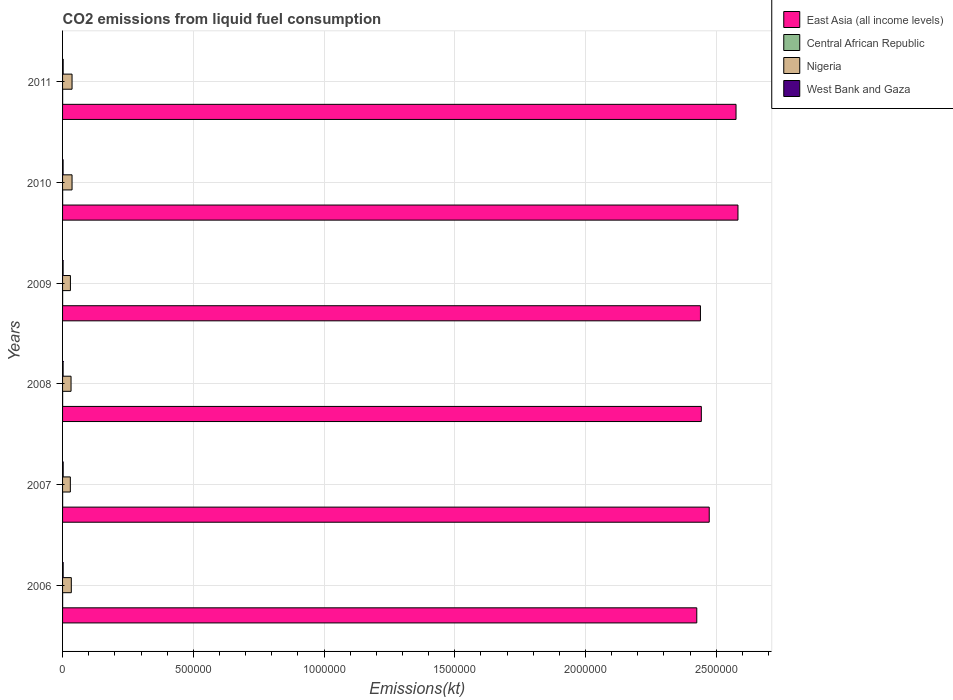How many groups of bars are there?
Keep it short and to the point. 6. Are the number of bars per tick equal to the number of legend labels?
Your answer should be very brief. Yes. How many bars are there on the 5th tick from the top?
Provide a short and direct response. 4. How many bars are there on the 2nd tick from the bottom?
Keep it short and to the point. 4. What is the label of the 5th group of bars from the top?
Make the answer very short. 2007. In how many cases, is the number of bars for a given year not equal to the number of legend labels?
Make the answer very short. 0. What is the amount of CO2 emitted in West Bank and Gaza in 2007?
Keep it short and to the point. 2324.88. Across all years, what is the maximum amount of CO2 emitted in East Asia (all income levels)?
Offer a very short reply. 2.58e+06. Across all years, what is the minimum amount of CO2 emitted in Nigeria?
Offer a terse response. 2.98e+04. In which year was the amount of CO2 emitted in West Bank and Gaza maximum?
Your answer should be very brief. 2007. In which year was the amount of CO2 emitted in Nigeria minimum?
Your response must be concise. 2007. What is the total amount of CO2 emitted in Central African Republic in the graph?
Give a very brief answer. 1481.47. What is the difference between the amount of CO2 emitted in West Bank and Gaza in 2006 and that in 2010?
Offer a very short reply. 231.02. What is the difference between the amount of CO2 emitted in Central African Republic in 2006 and the amount of CO2 emitted in Nigeria in 2007?
Provide a succinct answer. -2.95e+04. What is the average amount of CO2 emitted in Central African Republic per year?
Offer a terse response. 246.91. In the year 2010, what is the difference between the amount of CO2 emitted in West Bank and Gaza and amount of CO2 emitted in Nigeria?
Your answer should be very brief. -3.42e+04. What is the ratio of the amount of CO2 emitted in West Bank and Gaza in 2009 to that in 2010?
Offer a terse response. 1.03. What is the difference between the highest and the second highest amount of CO2 emitted in West Bank and Gaza?
Offer a very short reply. 58.67. What is the difference between the highest and the lowest amount of CO2 emitted in West Bank and Gaza?
Your response must be concise. 289.69. In how many years, is the amount of CO2 emitted in West Bank and Gaza greater than the average amount of CO2 emitted in West Bank and Gaza taken over all years?
Provide a short and direct response. 3. Is the sum of the amount of CO2 emitted in Central African Republic in 2008 and 2009 greater than the maximum amount of CO2 emitted in West Bank and Gaza across all years?
Make the answer very short. No. Is it the case that in every year, the sum of the amount of CO2 emitted in West Bank and Gaza and amount of CO2 emitted in Nigeria is greater than the sum of amount of CO2 emitted in East Asia (all income levels) and amount of CO2 emitted in Central African Republic?
Your answer should be compact. No. What does the 4th bar from the top in 2008 represents?
Give a very brief answer. East Asia (all income levels). What does the 1st bar from the bottom in 2011 represents?
Provide a short and direct response. East Asia (all income levels). Is it the case that in every year, the sum of the amount of CO2 emitted in West Bank and Gaza and amount of CO2 emitted in Central African Republic is greater than the amount of CO2 emitted in East Asia (all income levels)?
Ensure brevity in your answer.  No. How many bars are there?
Offer a terse response. 24. Are all the bars in the graph horizontal?
Your answer should be compact. Yes. How many years are there in the graph?
Give a very brief answer. 6. Does the graph contain any zero values?
Provide a succinct answer. No. Does the graph contain grids?
Your answer should be very brief. Yes. Where does the legend appear in the graph?
Provide a succinct answer. Top right. How are the legend labels stacked?
Your answer should be compact. Vertical. What is the title of the graph?
Give a very brief answer. CO2 emissions from liquid fuel consumption. What is the label or title of the X-axis?
Provide a succinct answer. Emissions(kt). What is the label or title of the Y-axis?
Offer a terse response. Years. What is the Emissions(kt) in East Asia (all income levels) in 2006?
Give a very brief answer. 2.43e+06. What is the Emissions(kt) of Central African Republic in 2006?
Offer a very short reply. 227.35. What is the Emissions(kt) in Nigeria in 2006?
Offer a very short reply. 3.35e+04. What is the Emissions(kt) in West Bank and Gaza in 2006?
Give a very brief answer. 2266.21. What is the Emissions(kt) of East Asia (all income levels) in 2007?
Provide a short and direct response. 2.47e+06. What is the Emissions(kt) of Central African Republic in 2007?
Offer a terse response. 234.69. What is the Emissions(kt) of Nigeria in 2007?
Keep it short and to the point. 2.98e+04. What is the Emissions(kt) in West Bank and Gaza in 2007?
Keep it short and to the point. 2324.88. What is the Emissions(kt) in East Asia (all income levels) in 2008?
Offer a very short reply. 2.44e+06. What is the Emissions(kt) in Central African Republic in 2008?
Ensure brevity in your answer.  234.69. What is the Emissions(kt) of Nigeria in 2008?
Your answer should be compact. 3.25e+04. What is the Emissions(kt) in West Bank and Gaza in 2008?
Offer a very short reply. 2053.52. What is the Emissions(kt) in East Asia (all income levels) in 2009?
Offer a very short reply. 2.44e+06. What is the Emissions(kt) of Central African Republic in 2009?
Make the answer very short. 234.69. What is the Emissions(kt) of Nigeria in 2009?
Make the answer very short. 3.00e+04. What is the Emissions(kt) in West Bank and Gaza in 2009?
Your answer should be very brief. 2090.19. What is the Emissions(kt) in East Asia (all income levels) in 2010?
Your answer should be very brief. 2.58e+06. What is the Emissions(kt) of Central African Republic in 2010?
Give a very brief answer. 264.02. What is the Emissions(kt) of Nigeria in 2010?
Keep it short and to the point. 3.63e+04. What is the Emissions(kt) in West Bank and Gaza in 2010?
Make the answer very short. 2035.18. What is the Emissions(kt) in East Asia (all income levels) in 2011?
Your answer should be very brief. 2.58e+06. What is the Emissions(kt) of Central African Republic in 2011?
Your response must be concise. 286.03. What is the Emissions(kt) of Nigeria in 2011?
Your answer should be very brief. 3.63e+04. What is the Emissions(kt) in West Bank and Gaza in 2011?
Offer a terse response. 2247.87. Across all years, what is the maximum Emissions(kt) of East Asia (all income levels)?
Offer a very short reply. 2.58e+06. Across all years, what is the maximum Emissions(kt) in Central African Republic?
Provide a short and direct response. 286.03. Across all years, what is the maximum Emissions(kt) in Nigeria?
Your answer should be compact. 3.63e+04. Across all years, what is the maximum Emissions(kt) in West Bank and Gaza?
Ensure brevity in your answer.  2324.88. Across all years, what is the minimum Emissions(kt) in East Asia (all income levels)?
Give a very brief answer. 2.43e+06. Across all years, what is the minimum Emissions(kt) of Central African Republic?
Keep it short and to the point. 227.35. Across all years, what is the minimum Emissions(kt) of Nigeria?
Ensure brevity in your answer.  2.98e+04. Across all years, what is the minimum Emissions(kt) in West Bank and Gaza?
Provide a succinct answer. 2035.18. What is the total Emissions(kt) of East Asia (all income levels) in the graph?
Keep it short and to the point. 1.49e+07. What is the total Emissions(kt) of Central African Republic in the graph?
Offer a terse response. 1481.47. What is the total Emissions(kt) in Nigeria in the graph?
Your response must be concise. 1.98e+05. What is the total Emissions(kt) of West Bank and Gaza in the graph?
Keep it short and to the point. 1.30e+04. What is the difference between the Emissions(kt) in East Asia (all income levels) in 2006 and that in 2007?
Your response must be concise. -4.77e+04. What is the difference between the Emissions(kt) of Central African Republic in 2006 and that in 2007?
Offer a terse response. -7.33. What is the difference between the Emissions(kt) in Nigeria in 2006 and that in 2007?
Your answer should be very brief. 3722.01. What is the difference between the Emissions(kt) in West Bank and Gaza in 2006 and that in 2007?
Provide a succinct answer. -58.67. What is the difference between the Emissions(kt) in East Asia (all income levels) in 2006 and that in 2008?
Make the answer very short. -1.74e+04. What is the difference between the Emissions(kt) of Central African Republic in 2006 and that in 2008?
Make the answer very short. -7.33. What is the difference between the Emissions(kt) in Nigeria in 2006 and that in 2008?
Your response must be concise. 1015.76. What is the difference between the Emissions(kt) of West Bank and Gaza in 2006 and that in 2008?
Provide a short and direct response. 212.69. What is the difference between the Emissions(kt) in East Asia (all income levels) in 2006 and that in 2009?
Ensure brevity in your answer.  -1.40e+04. What is the difference between the Emissions(kt) in Central African Republic in 2006 and that in 2009?
Offer a very short reply. -7.33. What is the difference between the Emissions(kt) of Nigeria in 2006 and that in 2009?
Keep it short and to the point. 3439.65. What is the difference between the Emissions(kt) of West Bank and Gaza in 2006 and that in 2009?
Provide a succinct answer. 176.02. What is the difference between the Emissions(kt) of East Asia (all income levels) in 2006 and that in 2010?
Keep it short and to the point. -1.58e+05. What is the difference between the Emissions(kt) in Central African Republic in 2006 and that in 2010?
Your answer should be very brief. -36.67. What is the difference between the Emissions(kt) of Nigeria in 2006 and that in 2010?
Give a very brief answer. -2794.25. What is the difference between the Emissions(kt) in West Bank and Gaza in 2006 and that in 2010?
Keep it short and to the point. 231.02. What is the difference between the Emissions(kt) in East Asia (all income levels) in 2006 and that in 2011?
Offer a very short reply. -1.50e+05. What is the difference between the Emissions(kt) of Central African Republic in 2006 and that in 2011?
Provide a short and direct response. -58.67. What is the difference between the Emissions(kt) of Nigeria in 2006 and that in 2011?
Keep it short and to the point. -2805.26. What is the difference between the Emissions(kt) in West Bank and Gaza in 2006 and that in 2011?
Your answer should be compact. 18.34. What is the difference between the Emissions(kt) of East Asia (all income levels) in 2007 and that in 2008?
Your answer should be very brief. 3.02e+04. What is the difference between the Emissions(kt) in Nigeria in 2007 and that in 2008?
Provide a succinct answer. -2706.25. What is the difference between the Emissions(kt) in West Bank and Gaza in 2007 and that in 2008?
Your answer should be very brief. 271.36. What is the difference between the Emissions(kt) of East Asia (all income levels) in 2007 and that in 2009?
Offer a very short reply. 3.36e+04. What is the difference between the Emissions(kt) in Central African Republic in 2007 and that in 2009?
Provide a succinct answer. 0. What is the difference between the Emissions(kt) in Nigeria in 2007 and that in 2009?
Provide a short and direct response. -282.36. What is the difference between the Emissions(kt) of West Bank and Gaza in 2007 and that in 2009?
Make the answer very short. 234.69. What is the difference between the Emissions(kt) in East Asia (all income levels) in 2007 and that in 2010?
Your answer should be very brief. -1.10e+05. What is the difference between the Emissions(kt) of Central African Republic in 2007 and that in 2010?
Keep it short and to the point. -29.34. What is the difference between the Emissions(kt) of Nigeria in 2007 and that in 2010?
Your answer should be compact. -6516.26. What is the difference between the Emissions(kt) of West Bank and Gaza in 2007 and that in 2010?
Provide a succinct answer. 289.69. What is the difference between the Emissions(kt) of East Asia (all income levels) in 2007 and that in 2011?
Offer a very short reply. -1.02e+05. What is the difference between the Emissions(kt) in Central African Republic in 2007 and that in 2011?
Ensure brevity in your answer.  -51.34. What is the difference between the Emissions(kt) in Nigeria in 2007 and that in 2011?
Ensure brevity in your answer.  -6527.26. What is the difference between the Emissions(kt) in West Bank and Gaza in 2007 and that in 2011?
Provide a short and direct response. 77.01. What is the difference between the Emissions(kt) in East Asia (all income levels) in 2008 and that in 2009?
Make the answer very short. 3400.93. What is the difference between the Emissions(kt) in Central African Republic in 2008 and that in 2009?
Your answer should be very brief. 0. What is the difference between the Emissions(kt) in Nigeria in 2008 and that in 2009?
Your response must be concise. 2423.89. What is the difference between the Emissions(kt) of West Bank and Gaza in 2008 and that in 2009?
Provide a succinct answer. -36.67. What is the difference between the Emissions(kt) in East Asia (all income levels) in 2008 and that in 2010?
Offer a terse response. -1.40e+05. What is the difference between the Emissions(kt) in Central African Republic in 2008 and that in 2010?
Your answer should be compact. -29.34. What is the difference between the Emissions(kt) in Nigeria in 2008 and that in 2010?
Offer a very short reply. -3810.01. What is the difference between the Emissions(kt) of West Bank and Gaza in 2008 and that in 2010?
Give a very brief answer. 18.34. What is the difference between the Emissions(kt) of East Asia (all income levels) in 2008 and that in 2011?
Ensure brevity in your answer.  -1.33e+05. What is the difference between the Emissions(kt) of Central African Republic in 2008 and that in 2011?
Make the answer very short. -51.34. What is the difference between the Emissions(kt) of Nigeria in 2008 and that in 2011?
Make the answer very short. -3821.01. What is the difference between the Emissions(kt) in West Bank and Gaza in 2008 and that in 2011?
Your response must be concise. -194.35. What is the difference between the Emissions(kt) in East Asia (all income levels) in 2009 and that in 2010?
Provide a short and direct response. -1.44e+05. What is the difference between the Emissions(kt) in Central African Republic in 2009 and that in 2010?
Your answer should be compact. -29.34. What is the difference between the Emissions(kt) of Nigeria in 2009 and that in 2010?
Make the answer very short. -6233.9. What is the difference between the Emissions(kt) of West Bank and Gaza in 2009 and that in 2010?
Your response must be concise. 55.01. What is the difference between the Emissions(kt) in East Asia (all income levels) in 2009 and that in 2011?
Your answer should be compact. -1.36e+05. What is the difference between the Emissions(kt) of Central African Republic in 2009 and that in 2011?
Keep it short and to the point. -51.34. What is the difference between the Emissions(kt) in Nigeria in 2009 and that in 2011?
Your response must be concise. -6244.9. What is the difference between the Emissions(kt) in West Bank and Gaza in 2009 and that in 2011?
Offer a very short reply. -157.68. What is the difference between the Emissions(kt) of East Asia (all income levels) in 2010 and that in 2011?
Your answer should be compact. 7429.65. What is the difference between the Emissions(kt) in Central African Republic in 2010 and that in 2011?
Give a very brief answer. -22. What is the difference between the Emissions(kt) of Nigeria in 2010 and that in 2011?
Offer a very short reply. -11. What is the difference between the Emissions(kt) in West Bank and Gaza in 2010 and that in 2011?
Give a very brief answer. -212.69. What is the difference between the Emissions(kt) in East Asia (all income levels) in 2006 and the Emissions(kt) in Central African Republic in 2007?
Provide a succinct answer. 2.43e+06. What is the difference between the Emissions(kt) in East Asia (all income levels) in 2006 and the Emissions(kt) in Nigeria in 2007?
Provide a short and direct response. 2.40e+06. What is the difference between the Emissions(kt) of East Asia (all income levels) in 2006 and the Emissions(kt) of West Bank and Gaza in 2007?
Your answer should be compact. 2.42e+06. What is the difference between the Emissions(kt) of Central African Republic in 2006 and the Emissions(kt) of Nigeria in 2007?
Your response must be concise. -2.95e+04. What is the difference between the Emissions(kt) of Central African Republic in 2006 and the Emissions(kt) of West Bank and Gaza in 2007?
Give a very brief answer. -2097.52. What is the difference between the Emissions(kt) of Nigeria in 2006 and the Emissions(kt) of West Bank and Gaza in 2007?
Offer a terse response. 3.12e+04. What is the difference between the Emissions(kt) of East Asia (all income levels) in 2006 and the Emissions(kt) of Central African Republic in 2008?
Your answer should be very brief. 2.43e+06. What is the difference between the Emissions(kt) of East Asia (all income levels) in 2006 and the Emissions(kt) of Nigeria in 2008?
Make the answer very short. 2.39e+06. What is the difference between the Emissions(kt) in East Asia (all income levels) in 2006 and the Emissions(kt) in West Bank and Gaza in 2008?
Offer a very short reply. 2.42e+06. What is the difference between the Emissions(kt) in Central African Republic in 2006 and the Emissions(kt) in Nigeria in 2008?
Ensure brevity in your answer.  -3.22e+04. What is the difference between the Emissions(kt) of Central African Republic in 2006 and the Emissions(kt) of West Bank and Gaza in 2008?
Ensure brevity in your answer.  -1826.17. What is the difference between the Emissions(kt) of Nigeria in 2006 and the Emissions(kt) of West Bank and Gaza in 2008?
Provide a succinct answer. 3.14e+04. What is the difference between the Emissions(kt) in East Asia (all income levels) in 2006 and the Emissions(kt) in Central African Republic in 2009?
Keep it short and to the point. 2.43e+06. What is the difference between the Emissions(kt) of East Asia (all income levels) in 2006 and the Emissions(kt) of Nigeria in 2009?
Give a very brief answer. 2.40e+06. What is the difference between the Emissions(kt) of East Asia (all income levels) in 2006 and the Emissions(kt) of West Bank and Gaza in 2009?
Your answer should be compact. 2.42e+06. What is the difference between the Emissions(kt) in Central African Republic in 2006 and the Emissions(kt) in Nigeria in 2009?
Offer a very short reply. -2.98e+04. What is the difference between the Emissions(kt) in Central African Republic in 2006 and the Emissions(kt) in West Bank and Gaza in 2009?
Give a very brief answer. -1862.84. What is the difference between the Emissions(kt) in Nigeria in 2006 and the Emissions(kt) in West Bank and Gaza in 2009?
Ensure brevity in your answer.  3.14e+04. What is the difference between the Emissions(kt) of East Asia (all income levels) in 2006 and the Emissions(kt) of Central African Republic in 2010?
Offer a very short reply. 2.43e+06. What is the difference between the Emissions(kt) in East Asia (all income levels) in 2006 and the Emissions(kt) in Nigeria in 2010?
Give a very brief answer. 2.39e+06. What is the difference between the Emissions(kt) of East Asia (all income levels) in 2006 and the Emissions(kt) of West Bank and Gaza in 2010?
Keep it short and to the point. 2.42e+06. What is the difference between the Emissions(kt) in Central African Republic in 2006 and the Emissions(kt) in Nigeria in 2010?
Offer a terse response. -3.60e+04. What is the difference between the Emissions(kt) in Central African Republic in 2006 and the Emissions(kt) in West Bank and Gaza in 2010?
Your answer should be compact. -1807.83. What is the difference between the Emissions(kt) in Nigeria in 2006 and the Emissions(kt) in West Bank and Gaza in 2010?
Offer a very short reply. 3.14e+04. What is the difference between the Emissions(kt) of East Asia (all income levels) in 2006 and the Emissions(kt) of Central African Republic in 2011?
Offer a very short reply. 2.43e+06. What is the difference between the Emissions(kt) of East Asia (all income levels) in 2006 and the Emissions(kt) of Nigeria in 2011?
Your answer should be very brief. 2.39e+06. What is the difference between the Emissions(kt) in East Asia (all income levels) in 2006 and the Emissions(kt) in West Bank and Gaza in 2011?
Offer a terse response. 2.42e+06. What is the difference between the Emissions(kt) in Central African Republic in 2006 and the Emissions(kt) in Nigeria in 2011?
Offer a very short reply. -3.61e+04. What is the difference between the Emissions(kt) of Central African Republic in 2006 and the Emissions(kt) of West Bank and Gaza in 2011?
Ensure brevity in your answer.  -2020.52. What is the difference between the Emissions(kt) of Nigeria in 2006 and the Emissions(kt) of West Bank and Gaza in 2011?
Your answer should be very brief. 3.12e+04. What is the difference between the Emissions(kt) of East Asia (all income levels) in 2007 and the Emissions(kt) of Central African Republic in 2008?
Offer a very short reply. 2.47e+06. What is the difference between the Emissions(kt) in East Asia (all income levels) in 2007 and the Emissions(kt) in Nigeria in 2008?
Keep it short and to the point. 2.44e+06. What is the difference between the Emissions(kt) of East Asia (all income levels) in 2007 and the Emissions(kt) of West Bank and Gaza in 2008?
Provide a succinct answer. 2.47e+06. What is the difference between the Emissions(kt) in Central African Republic in 2007 and the Emissions(kt) in Nigeria in 2008?
Provide a succinct answer. -3.22e+04. What is the difference between the Emissions(kt) of Central African Republic in 2007 and the Emissions(kt) of West Bank and Gaza in 2008?
Provide a succinct answer. -1818.83. What is the difference between the Emissions(kt) of Nigeria in 2007 and the Emissions(kt) of West Bank and Gaza in 2008?
Provide a short and direct response. 2.77e+04. What is the difference between the Emissions(kt) in East Asia (all income levels) in 2007 and the Emissions(kt) in Central African Republic in 2009?
Provide a succinct answer. 2.47e+06. What is the difference between the Emissions(kt) in East Asia (all income levels) in 2007 and the Emissions(kt) in Nigeria in 2009?
Provide a succinct answer. 2.44e+06. What is the difference between the Emissions(kt) in East Asia (all income levels) in 2007 and the Emissions(kt) in West Bank and Gaza in 2009?
Your answer should be very brief. 2.47e+06. What is the difference between the Emissions(kt) in Central African Republic in 2007 and the Emissions(kt) in Nigeria in 2009?
Your answer should be very brief. -2.98e+04. What is the difference between the Emissions(kt) of Central African Republic in 2007 and the Emissions(kt) of West Bank and Gaza in 2009?
Your answer should be compact. -1855.5. What is the difference between the Emissions(kt) of Nigeria in 2007 and the Emissions(kt) of West Bank and Gaza in 2009?
Give a very brief answer. 2.77e+04. What is the difference between the Emissions(kt) of East Asia (all income levels) in 2007 and the Emissions(kt) of Central African Republic in 2010?
Ensure brevity in your answer.  2.47e+06. What is the difference between the Emissions(kt) of East Asia (all income levels) in 2007 and the Emissions(kt) of Nigeria in 2010?
Provide a short and direct response. 2.44e+06. What is the difference between the Emissions(kt) of East Asia (all income levels) in 2007 and the Emissions(kt) of West Bank and Gaza in 2010?
Give a very brief answer. 2.47e+06. What is the difference between the Emissions(kt) in Central African Republic in 2007 and the Emissions(kt) in Nigeria in 2010?
Your response must be concise. -3.60e+04. What is the difference between the Emissions(kt) of Central African Republic in 2007 and the Emissions(kt) of West Bank and Gaza in 2010?
Give a very brief answer. -1800.5. What is the difference between the Emissions(kt) in Nigeria in 2007 and the Emissions(kt) in West Bank and Gaza in 2010?
Provide a short and direct response. 2.77e+04. What is the difference between the Emissions(kt) of East Asia (all income levels) in 2007 and the Emissions(kt) of Central African Republic in 2011?
Your answer should be very brief. 2.47e+06. What is the difference between the Emissions(kt) in East Asia (all income levels) in 2007 and the Emissions(kt) in Nigeria in 2011?
Provide a succinct answer. 2.44e+06. What is the difference between the Emissions(kt) in East Asia (all income levels) in 2007 and the Emissions(kt) in West Bank and Gaza in 2011?
Your response must be concise. 2.47e+06. What is the difference between the Emissions(kt) of Central African Republic in 2007 and the Emissions(kt) of Nigeria in 2011?
Offer a terse response. -3.61e+04. What is the difference between the Emissions(kt) in Central African Republic in 2007 and the Emissions(kt) in West Bank and Gaza in 2011?
Keep it short and to the point. -2013.18. What is the difference between the Emissions(kt) in Nigeria in 2007 and the Emissions(kt) in West Bank and Gaza in 2011?
Offer a very short reply. 2.75e+04. What is the difference between the Emissions(kt) in East Asia (all income levels) in 2008 and the Emissions(kt) in Central African Republic in 2009?
Offer a very short reply. 2.44e+06. What is the difference between the Emissions(kt) of East Asia (all income levels) in 2008 and the Emissions(kt) of Nigeria in 2009?
Your response must be concise. 2.41e+06. What is the difference between the Emissions(kt) in East Asia (all income levels) in 2008 and the Emissions(kt) in West Bank and Gaza in 2009?
Keep it short and to the point. 2.44e+06. What is the difference between the Emissions(kt) of Central African Republic in 2008 and the Emissions(kt) of Nigeria in 2009?
Your answer should be very brief. -2.98e+04. What is the difference between the Emissions(kt) in Central African Republic in 2008 and the Emissions(kt) in West Bank and Gaza in 2009?
Offer a very short reply. -1855.5. What is the difference between the Emissions(kt) in Nigeria in 2008 and the Emissions(kt) in West Bank and Gaza in 2009?
Your answer should be compact. 3.04e+04. What is the difference between the Emissions(kt) in East Asia (all income levels) in 2008 and the Emissions(kt) in Central African Republic in 2010?
Offer a terse response. 2.44e+06. What is the difference between the Emissions(kt) in East Asia (all income levels) in 2008 and the Emissions(kt) in Nigeria in 2010?
Offer a terse response. 2.41e+06. What is the difference between the Emissions(kt) in East Asia (all income levels) in 2008 and the Emissions(kt) in West Bank and Gaza in 2010?
Your answer should be very brief. 2.44e+06. What is the difference between the Emissions(kt) in Central African Republic in 2008 and the Emissions(kt) in Nigeria in 2010?
Make the answer very short. -3.60e+04. What is the difference between the Emissions(kt) of Central African Republic in 2008 and the Emissions(kt) of West Bank and Gaza in 2010?
Make the answer very short. -1800.5. What is the difference between the Emissions(kt) of Nigeria in 2008 and the Emissions(kt) of West Bank and Gaza in 2010?
Ensure brevity in your answer.  3.04e+04. What is the difference between the Emissions(kt) in East Asia (all income levels) in 2008 and the Emissions(kt) in Central African Republic in 2011?
Provide a short and direct response. 2.44e+06. What is the difference between the Emissions(kt) of East Asia (all income levels) in 2008 and the Emissions(kt) of Nigeria in 2011?
Your answer should be compact. 2.41e+06. What is the difference between the Emissions(kt) in East Asia (all income levels) in 2008 and the Emissions(kt) in West Bank and Gaza in 2011?
Give a very brief answer. 2.44e+06. What is the difference between the Emissions(kt) of Central African Republic in 2008 and the Emissions(kt) of Nigeria in 2011?
Make the answer very short. -3.61e+04. What is the difference between the Emissions(kt) of Central African Republic in 2008 and the Emissions(kt) of West Bank and Gaza in 2011?
Your answer should be very brief. -2013.18. What is the difference between the Emissions(kt) in Nigeria in 2008 and the Emissions(kt) in West Bank and Gaza in 2011?
Provide a short and direct response. 3.02e+04. What is the difference between the Emissions(kt) of East Asia (all income levels) in 2009 and the Emissions(kt) of Central African Republic in 2010?
Keep it short and to the point. 2.44e+06. What is the difference between the Emissions(kt) of East Asia (all income levels) in 2009 and the Emissions(kt) of Nigeria in 2010?
Offer a terse response. 2.40e+06. What is the difference between the Emissions(kt) of East Asia (all income levels) in 2009 and the Emissions(kt) of West Bank and Gaza in 2010?
Your answer should be very brief. 2.44e+06. What is the difference between the Emissions(kt) of Central African Republic in 2009 and the Emissions(kt) of Nigeria in 2010?
Your answer should be very brief. -3.60e+04. What is the difference between the Emissions(kt) in Central African Republic in 2009 and the Emissions(kt) in West Bank and Gaza in 2010?
Ensure brevity in your answer.  -1800.5. What is the difference between the Emissions(kt) in Nigeria in 2009 and the Emissions(kt) in West Bank and Gaza in 2010?
Give a very brief answer. 2.80e+04. What is the difference between the Emissions(kt) in East Asia (all income levels) in 2009 and the Emissions(kt) in Central African Republic in 2011?
Your answer should be compact. 2.44e+06. What is the difference between the Emissions(kt) of East Asia (all income levels) in 2009 and the Emissions(kt) of Nigeria in 2011?
Make the answer very short. 2.40e+06. What is the difference between the Emissions(kt) in East Asia (all income levels) in 2009 and the Emissions(kt) in West Bank and Gaza in 2011?
Your answer should be very brief. 2.44e+06. What is the difference between the Emissions(kt) in Central African Republic in 2009 and the Emissions(kt) in Nigeria in 2011?
Make the answer very short. -3.61e+04. What is the difference between the Emissions(kt) in Central African Republic in 2009 and the Emissions(kt) in West Bank and Gaza in 2011?
Ensure brevity in your answer.  -2013.18. What is the difference between the Emissions(kt) in Nigeria in 2009 and the Emissions(kt) in West Bank and Gaza in 2011?
Offer a very short reply. 2.78e+04. What is the difference between the Emissions(kt) of East Asia (all income levels) in 2010 and the Emissions(kt) of Central African Republic in 2011?
Provide a succinct answer. 2.58e+06. What is the difference between the Emissions(kt) of East Asia (all income levels) in 2010 and the Emissions(kt) of Nigeria in 2011?
Provide a succinct answer. 2.55e+06. What is the difference between the Emissions(kt) of East Asia (all income levels) in 2010 and the Emissions(kt) of West Bank and Gaza in 2011?
Give a very brief answer. 2.58e+06. What is the difference between the Emissions(kt) in Central African Republic in 2010 and the Emissions(kt) in Nigeria in 2011?
Give a very brief answer. -3.60e+04. What is the difference between the Emissions(kt) in Central African Republic in 2010 and the Emissions(kt) in West Bank and Gaza in 2011?
Provide a short and direct response. -1983.85. What is the difference between the Emissions(kt) of Nigeria in 2010 and the Emissions(kt) of West Bank and Gaza in 2011?
Make the answer very short. 3.40e+04. What is the average Emissions(kt) in East Asia (all income levels) per year?
Keep it short and to the point. 2.49e+06. What is the average Emissions(kt) in Central African Republic per year?
Your response must be concise. 246.91. What is the average Emissions(kt) in Nigeria per year?
Keep it short and to the point. 3.31e+04. What is the average Emissions(kt) of West Bank and Gaza per year?
Ensure brevity in your answer.  2169.64. In the year 2006, what is the difference between the Emissions(kt) in East Asia (all income levels) and Emissions(kt) in Central African Republic?
Offer a terse response. 2.43e+06. In the year 2006, what is the difference between the Emissions(kt) of East Asia (all income levels) and Emissions(kt) of Nigeria?
Your response must be concise. 2.39e+06. In the year 2006, what is the difference between the Emissions(kt) in East Asia (all income levels) and Emissions(kt) in West Bank and Gaza?
Provide a short and direct response. 2.42e+06. In the year 2006, what is the difference between the Emissions(kt) of Central African Republic and Emissions(kt) of Nigeria?
Provide a short and direct response. -3.33e+04. In the year 2006, what is the difference between the Emissions(kt) in Central African Republic and Emissions(kt) in West Bank and Gaza?
Ensure brevity in your answer.  -2038.85. In the year 2006, what is the difference between the Emissions(kt) of Nigeria and Emissions(kt) of West Bank and Gaza?
Offer a very short reply. 3.12e+04. In the year 2007, what is the difference between the Emissions(kt) of East Asia (all income levels) and Emissions(kt) of Central African Republic?
Your response must be concise. 2.47e+06. In the year 2007, what is the difference between the Emissions(kt) in East Asia (all income levels) and Emissions(kt) in Nigeria?
Offer a very short reply. 2.44e+06. In the year 2007, what is the difference between the Emissions(kt) in East Asia (all income levels) and Emissions(kt) in West Bank and Gaza?
Make the answer very short. 2.47e+06. In the year 2007, what is the difference between the Emissions(kt) in Central African Republic and Emissions(kt) in Nigeria?
Ensure brevity in your answer.  -2.95e+04. In the year 2007, what is the difference between the Emissions(kt) of Central African Republic and Emissions(kt) of West Bank and Gaza?
Give a very brief answer. -2090.19. In the year 2007, what is the difference between the Emissions(kt) of Nigeria and Emissions(kt) of West Bank and Gaza?
Ensure brevity in your answer.  2.74e+04. In the year 2008, what is the difference between the Emissions(kt) in East Asia (all income levels) and Emissions(kt) in Central African Republic?
Your response must be concise. 2.44e+06. In the year 2008, what is the difference between the Emissions(kt) in East Asia (all income levels) and Emissions(kt) in Nigeria?
Offer a terse response. 2.41e+06. In the year 2008, what is the difference between the Emissions(kt) of East Asia (all income levels) and Emissions(kt) of West Bank and Gaza?
Offer a terse response. 2.44e+06. In the year 2008, what is the difference between the Emissions(kt) in Central African Republic and Emissions(kt) in Nigeria?
Provide a succinct answer. -3.22e+04. In the year 2008, what is the difference between the Emissions(kt) in Central African Republic and Emissions(kt) in West Bank and Gaza?
Provide a succinct answer. -1818.83. In the year 2008, what is the difference between the Emissions(kt) in Nigeria and Emissions(kt) in West Bank and Gaza?
Ensure brevity in your answer.  3.04e+04. In the year 2009, what is the difference between the Emissions(kt) in East Asia (all income levels) and Emissions(kt) in Central African Republic?
Give a very brief answer. 2.44e+06. In the year 2009, what is the difference between the Emissions(kt) of East Asia (all income levels) and Emissions(kt) of Nigeria?
Provide a succinct answer. 2.41e+06. In the year 2009, what is the difference between the Emissions(kt) in East Asia (all income levels) and Emissions(kt) in West Bank and Gaza?
Your answer should be compact. 2.44e+06. In the year 2009, what is the difference between the Emissions(kt) in Central African Republic and Emissions(kt) in Nigeria?
Keep it short and to the point. -2.98e+04. In the year 2009, what is the difference between the Emissions(kt) in Central African Republic and Emissions(kt) in West Bank and Gaza?
Give a very brief answer. -1855.5. In the year 2009, what is the difference between the Emissions(kt) of Nigeria and Emissions(kt) of West Bank and Gaza?
Ensure brevity in your answer.  2.79e+04. In the year 2010, what is the difference between the Emissions(kt) in East Asia (all income levels) and Emissions(kt) in Central African Republic?
Your answer should be compact. 2.58e+06. In the year 2010, what is the difference between the Emissions(kt) in East Asia (all income levels) and Emissions(kt) in Nigeria?
Make the answer very short. 2.55e+06. In the year 2010, what is the difference between the Emissions(kt) of East Asia (all income levels) and Emissions(kt) of West Bank and Gaza?
Give a very brief answer. 2.58e+06. In the year 2010, what is the difference between the Emissions(kt) in Central African Republic and Emissions(kt) in Nigeria?
Provide a succinct answer. -3.60e+04. In the year 2010, what is the difference between the Emissions(kt) in Central African Republic and Emissions(kt) in West Bank and Gaza?
Ensure brevity in your answer.  -1771.16. In the year 2010, what is the difference between the Emissions(kt) of Nigeria and Emissions(kt) of West Bank and Gaza?
Offer a very short reply. 3.42e+04. In the year 2011, what is the difference between the Emissions(kt) in East Asia (all income levels) and Emissions(kt) in Central African Republic?
Your answer should be compact. 2.58e+06. In the year 2011, what is the difference between the Emissions(kt) of East Asia (all income levels) and Emissions(kt) of Nigeria?
Keep it short and to the point. 2.54e+06. In the year 2011, what is the difference between the Emissions(kt) in East Asia (all income levels) and Emissions(kt) in West Bank and Gaza?
Give a very brief answer. 2.57e+06. In the year 2011, what is the difference between the Emissions(kt) in Central African Republic and Emissions(kt) in Nigeria?
Make the answer very short. -3.60e+04. In the year 2011, what is the difference between the Emissions(kt) of Central African Republic and Emissions(kt) of West Bank and Gaza?
Offer a very short reply. -1961.85. In the year 2011, what is the difference between the Emissions(kt) in Nigeria and Emissions(kt) in West Bank and Gaza?
Your response must be concise. 3.40e+04. What is the ratio of the Emissions(kt) of East Asia (all income levels) in 2006 to that in 2007?
Give a very brief answer. 0.98. What is the ratio of the Emissions(kt) in Central African Republic in 2006 to that in 2007?
Provide a succinct answer. 0.97. What is the ratio of the Emissions(kt) of Nigeria in 2006 to that in 2007?
Your answer should be compact. 1.13. What is the ratio of the Emissions(kt) of West Bank and Gaza in 2006 to that in 2007?
Give a very brief answer. 0.97. What is the ratio of the Emissions(kt) of Central African Republic in 2006 to that in 2008?
Ensure brevity in your answer.  0.97. What is the ratio of the Emissions(kt) in Nigeria in 2006 to that in 2008?
Your answer should be very brief. 1.03. What is the ratio of the Emissions(kt) of West Bank and Gaza in 2006 to that in 2008?
Offer a terse response. 1.1. What is the ratio of the Emissions(kt) in Central African Republic in 2006 to that in 2009?
Give a very brief answer. 0.97. What is the ratio of the Emissions(kt) in Nigeria in 2006 to that in 2009?
Your answer should be compact. 1.11. What is the ratio of the Emissions(kt) in West Bank and Gaza in 2006 to that in 2009?
Ensure brevity in your answer.  1.08. What is the ratio of the Emissions(kt) of East Asia (all income levels) in 2006 to that in 2010?
Your answer should be compact. 0.94. What is the ratio of the Emissions(kt) of Central African Republic in 2006 to that in 2010?
Your response must be concise. 0.86. What is the ratio of the Emissions(kt) of Nigeria in 2006 to that in 2010?
Make the answer very short. 0.92. What is the ratio of the Emissions(kt) of West Bank and Gaza in 2006 to that in 2010?
Offer a terse response. 1.11. What is the ratio of the Emissions(kt) of East Asia (all income levels) in 2006 to that in 2011?
Your answer should be compact. 0.94. What is the ratio of the Emissions(kt) in Central African Republic in 2006 to that in 2011?
Keep it short and to the point. 0.79. What is the ratio of the Emissions(kt) of Nigeria in 2006 to that in 2011?
Ensure brevity in your answer.  0.92. What is the ratio of the Emissions(kt) in West Bank and Gaza in 2006 to that in 2011?
Your response must be concise. 1.01. What is the ratio of the Emissions(kt) in East Asia (all income levels) in 2007 to that in 2008?
Give a very brief answer. 1.01. What is the ratio of the Emissions(kt) of Central African Republic in 2007 to that in 2008?
Your answer should be compact. 1. What is the ratio of the Emissions(kt) in Nigeria in 2007 to that in 2008?
Offer a terse response. 0.92. What is the ratio of the Emissions(kt) in West Bank and Gaza in 2007 to that in 2008?
Keep it short and to the point. 1.13. What is the ratio of the Emissions(kt) of East Asia (all income levels) in 2007 to that in 2009?
Give a very brief answer. 1.01. What is the ratio of the Emissions(kt) in Central African Republic in 2007 to that in 2009?
Your answer should be compact. 1. What is the ratio of the Emissions(kt) of Nigeria in 2007 to that in 2009?
Give a very brief answer. 0.99. What is the ratio of the Emissions(kt) of West Bank and Gaza in 2007 to that in 2009?
Offer a terse response. 1.11. What is the ratio of the Emissions(kt) of East Asia (all income levels) in 2007 to that in 2010?
Keep it short and to the point. 0.96. What is the ratio of the Emissions(kt) of Central African Republic in 2007 to that in 2010?
Provide a succinct answer. 0.89. What is the ratio of the Emissions(kt) of Nigeria in 2007 to that in 2010?
Provide a succinct answer. 0.82. What is the ratio of the Emissions(kt) of West Bank and Gaza in 2007 to that in 2010?
Give a very brief answer. 1.14. What is the ratio of the Emissions(kt) of East Asia (all income levels) in 2007 to that in 2011?
Your answer should be very brief. 0.96. What is the ratio of the Emissions(kt) in Central African Republic in 2007 to that in 2011?
Keep it short and to the point. 0.82. What is the ratio of the Emissions(kt) of Nigeria in 2007 to that in 2011?
Your response must be concise. 0.82. What is the ratio of the Emissions(kt) in West Bank and Gaza in 2007 to that in 2011?
Provide a short and direct response. 1.03. What is the ratio of the Emissions(kt) of Central African Republic in 2008 to that in 2009?
Provide a succinct answer. 1. What is the ratio of the Emissions(kt) of Nigeria in 2008 to that in 2009?
Offer a very short reply. 1.08. What is the ratio of the Emissions(kt) of West Bank and Gaza in 2008 to that in 2009?
Your answer should be compact. 0.98. What is the ratio of the Emissions(kt) in East Asia (all income levels) in 2008 to that in 2010?
Your answer should be very brief. 0.95. What is the ratio of the Emissions(kt) in Central African Republic in 2008 to that in 2010?
Give a very brief answer. 0.89. What is the ratio of the Emissions(kt) in Nigeria in 2008 to that in 2010?
Make the answer very short. 0.9. What is the ratio of the Emissions(kt) of West Bank and Gaza in 2008 to that in 2010?
Make the answer very short. 1.01. What is the ratio of the Emissions(kt) in East Asia (all income levels) in 2008 to that in 2011?
Offer a very short reply. 0.95. What is the ratio of the Emissions(kt) of Central African Republic in 2008 to that in 2011?
Your answer should be very brief. 0.82. What is the ratio of the Emissions(kt) of Nigeria in 2008 to that in 2011?
Your answer should be compact. 0.89. What is the ratio of the Emissions(kt) in West Bank and Gaza in 2008 to that in 2011?
Your response must be concise. 0.91. What is the ratio of the Emissions(kt) in Central African Republic in 2009 to that in 2010?
Give a very brief answer. 0.89. What is the ratio of the Emissions(kt) in Nigeria in 2009 to that in 2010?
Give a very brief answer. 0.83. What is the ratio of the Emissions(kt) of East Asia (all income levels) in 2009 to that in 2011?
Give a very brief answer. 0.95. What is the ratio of the Emissions(kt) in Central African Republic in 2009 to that in 2011?
Your answer should be compact. 0.82. What is the ratio of the Emissions(kt) of Nigeria in 2009 to that in 2011?
Provide a short and direct response. 0.83. What is the ratio of the Emissions(kt) of West Bank and Gaza in 2009 to that in 2011?
Make the answer very short. 0.93. What is the ratio of the Emissions(kt) in East Asia (all income levels) in 2010 to that in 2011?
Your response must be concise. 1. What is the ratio of the Emissions(kt) in Central African Republic in 2010 to that in 2011?
Provide a short and direct response. 0.92. What is the ratio of the Emissions(kt) in West Bank and Gaza in 2010 to that in 2011?
Your answer should be compact. 0.91. What is the difference between the highest and the second highest Emissions(kt) of East Asia (all income levels)?
Offer a terse response. 7429.65. What is the difference between the highest and the second highest Emissions(kt) of Central African Republic?
Your response must be concise. 22. What is the difference between the highest and the second highest Emissions(kt) in Nigeria?
Your response must be concise. 11. What is the difference between the highest and the second highest Emissions(kt) of West Bank and Gaza?
Your response must be concise. 58.67. What is the difference between the highest and the lowest Emissions(kt) of East Asia (all income levels)?
Make the answer very short. 1.58e+05. What is the difference between the highest and the lowest Emissions(kt) in Central African Republic?
Your answer should be very brief. 58.67. What is the difference between the highest and the lowest Emissions(kt) in Nigeria?
Your answer should be compact. 6527.26. What is the difference between the highest and the lowest Emissions(kt) in West Bank and Gaza?
Your answer should be compact. 289.69. 